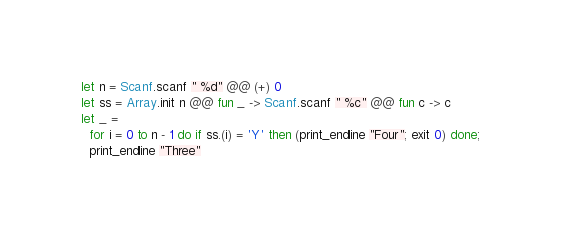<code> <loc_0><loc_0><loc_500><loc_500><_OCaml_>let n = Scanf.scanf " %d" @@ (+) 0
let ss = Array.init n @@ fun _ -> Scanf.scanf " %c" @@ fun c -> c
let _ =
  for i = 0 to n - 1 do if ss.(i) = 'Y' then (print_endline "Four"; exit 0) done;
  print_endline "Three"</code> 